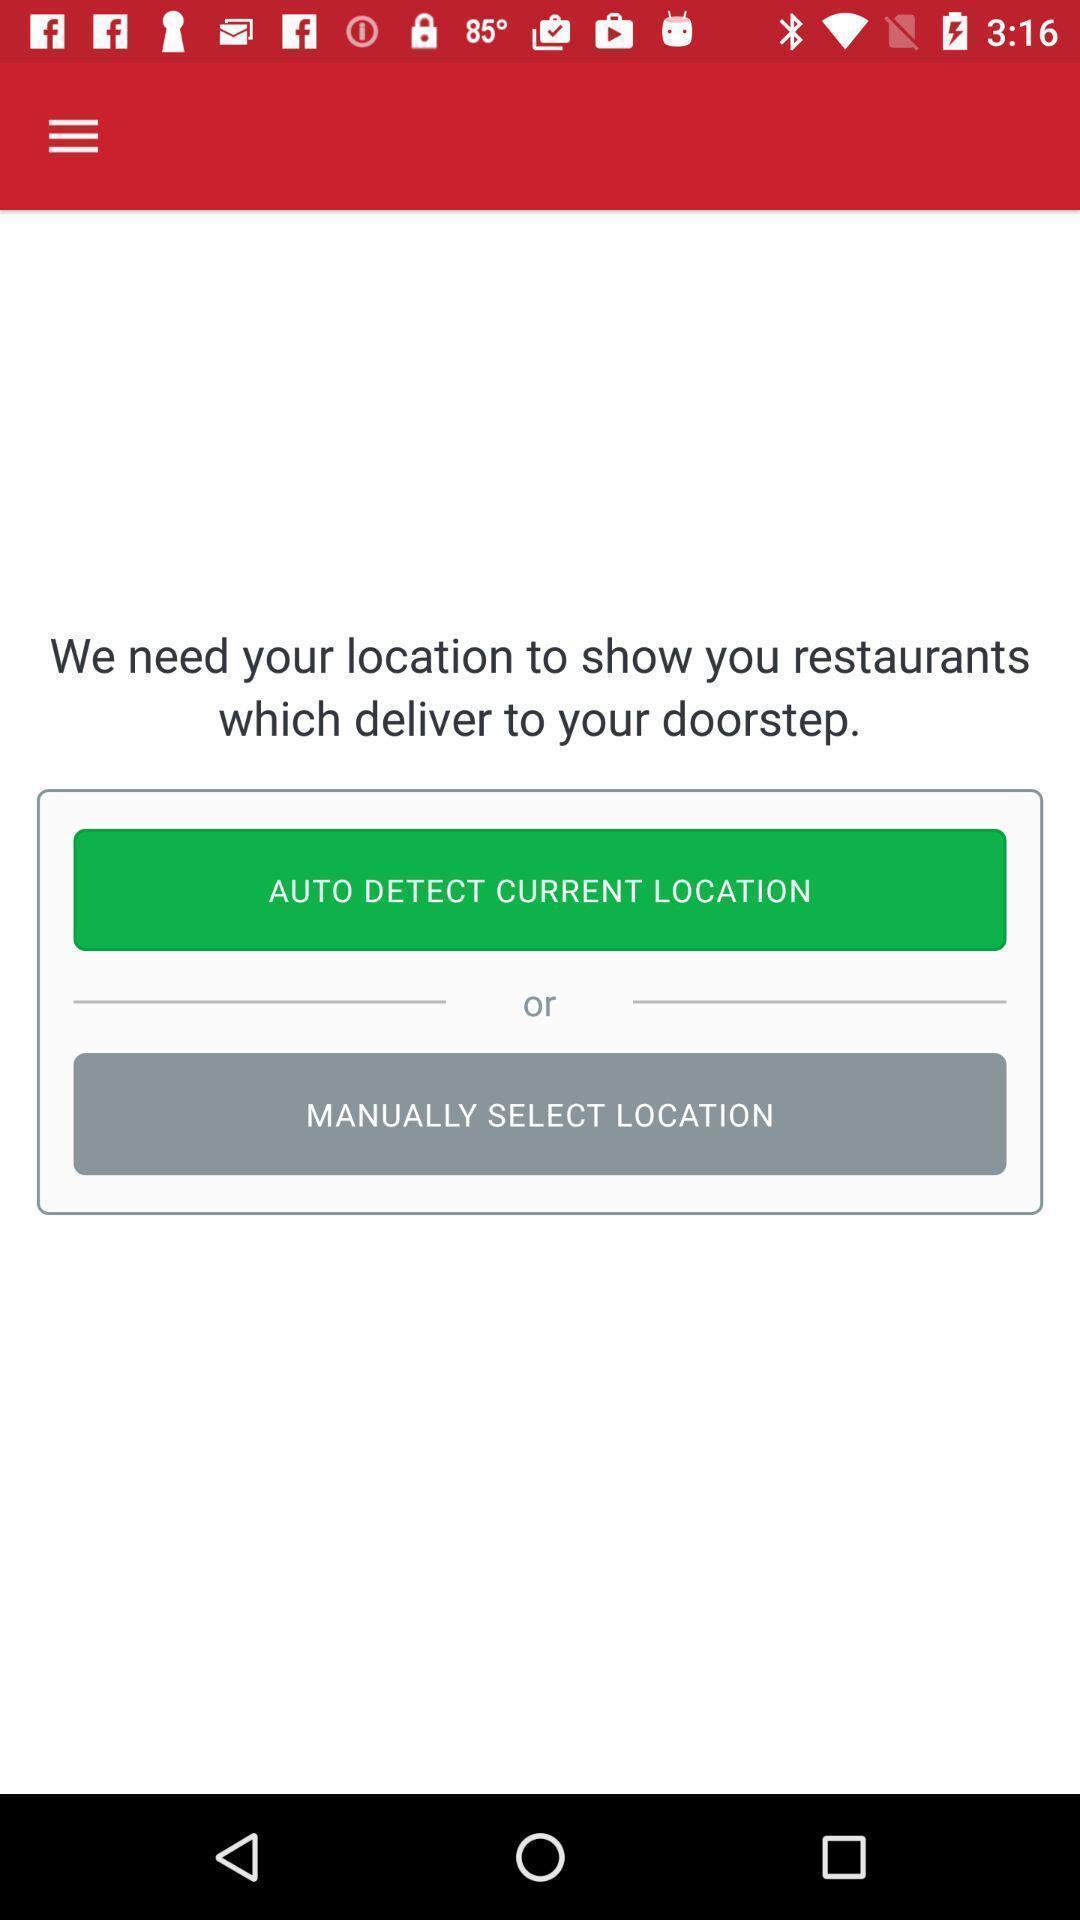Provide a textual representation of this image. Page showing option like auto detect current location. 